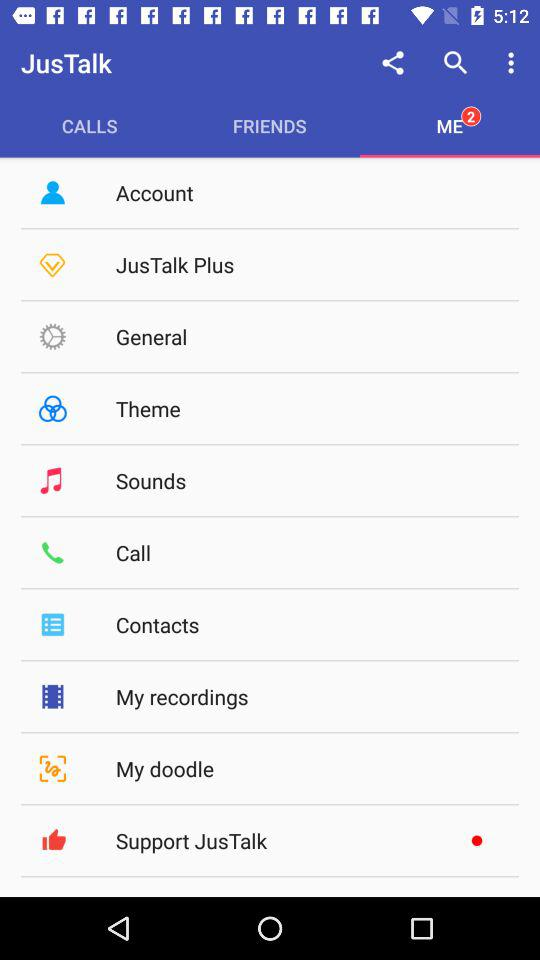What is the application name? The application name is "JusTalk". 